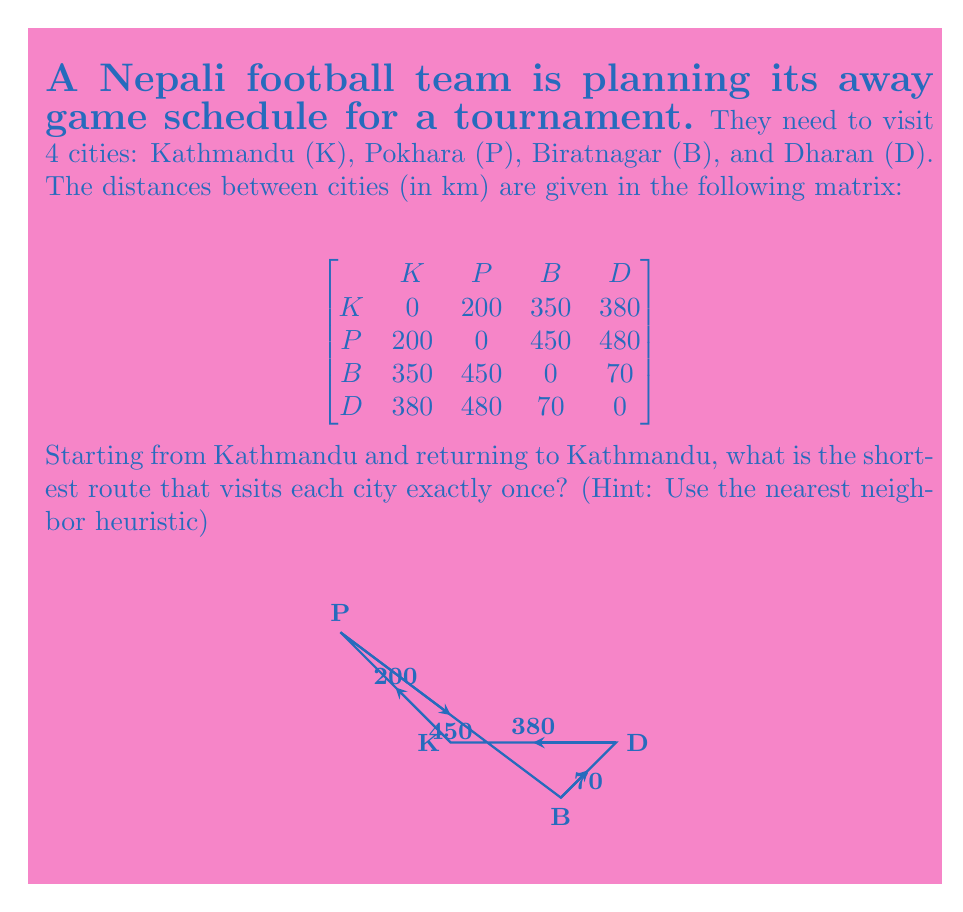Can you answer this question? Let's solve this using the nearest neighbor heuristic:

1) Start at Kathmandu (K).

2) Find the nearest unvisited city:
   K to P: 200 km
   K to B: 350 km
   K to D: 380 km
   Nearest is Pokhara (P), so go there.

3) From P, find the nearest unvisited city:
   P to B: 450 km
   P to D: 480 km
   Nearest is Biratnagar (B), so go there.

4) From B, the only unvisited city is Dharan (D):
   B to D: 70 km

5) From D, return to K:
   D to K: 380 km

6) Calculate total distance:
   $$ \text{Total} = 200 + 450 + 70 + 380 = 1100 \text{ km} $$

Therefore, the shortest route is K → P → B → D → K, with a total distance of 1100 km.
Answer: K → P → B → D → K, 1100 km 